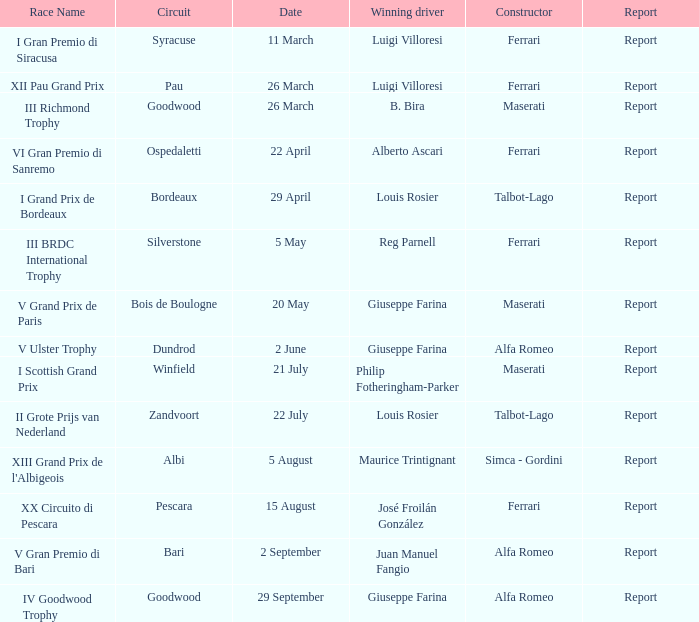Name the report on 20 may Report. 